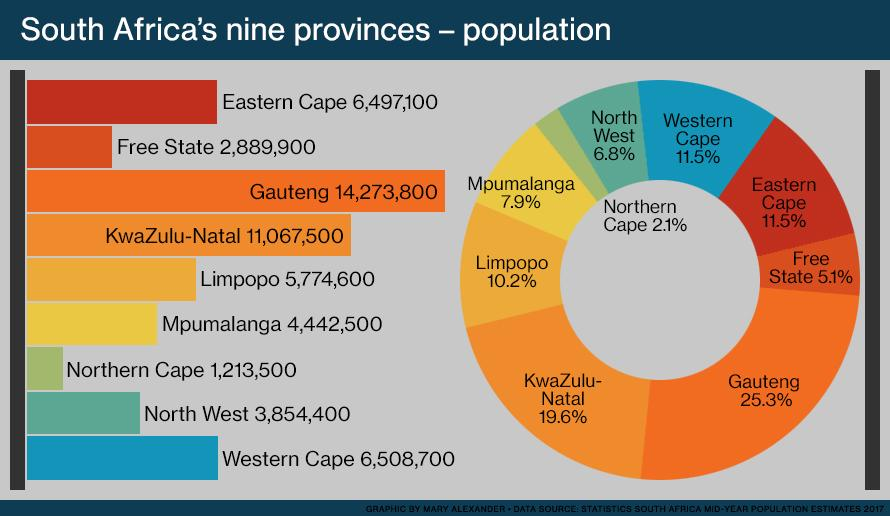Identify some key points in this picture. In Limpopo and Mpumalanga, taken together, approximately 18.1% of the population resides. According to the provided information, the combined population of Gauteng and KwaZulu-Natal is 44.9% of the total population. Approximately 16.6% of the population resides in the Free State and Eastern Cape provinces, combined. According to the provided information, the population of North West and Western Cape combined amounts to 18.3% of the total population in South Africa. Approximately 13.6% of the population resides in the Northern Cape and Western Cape combined. 